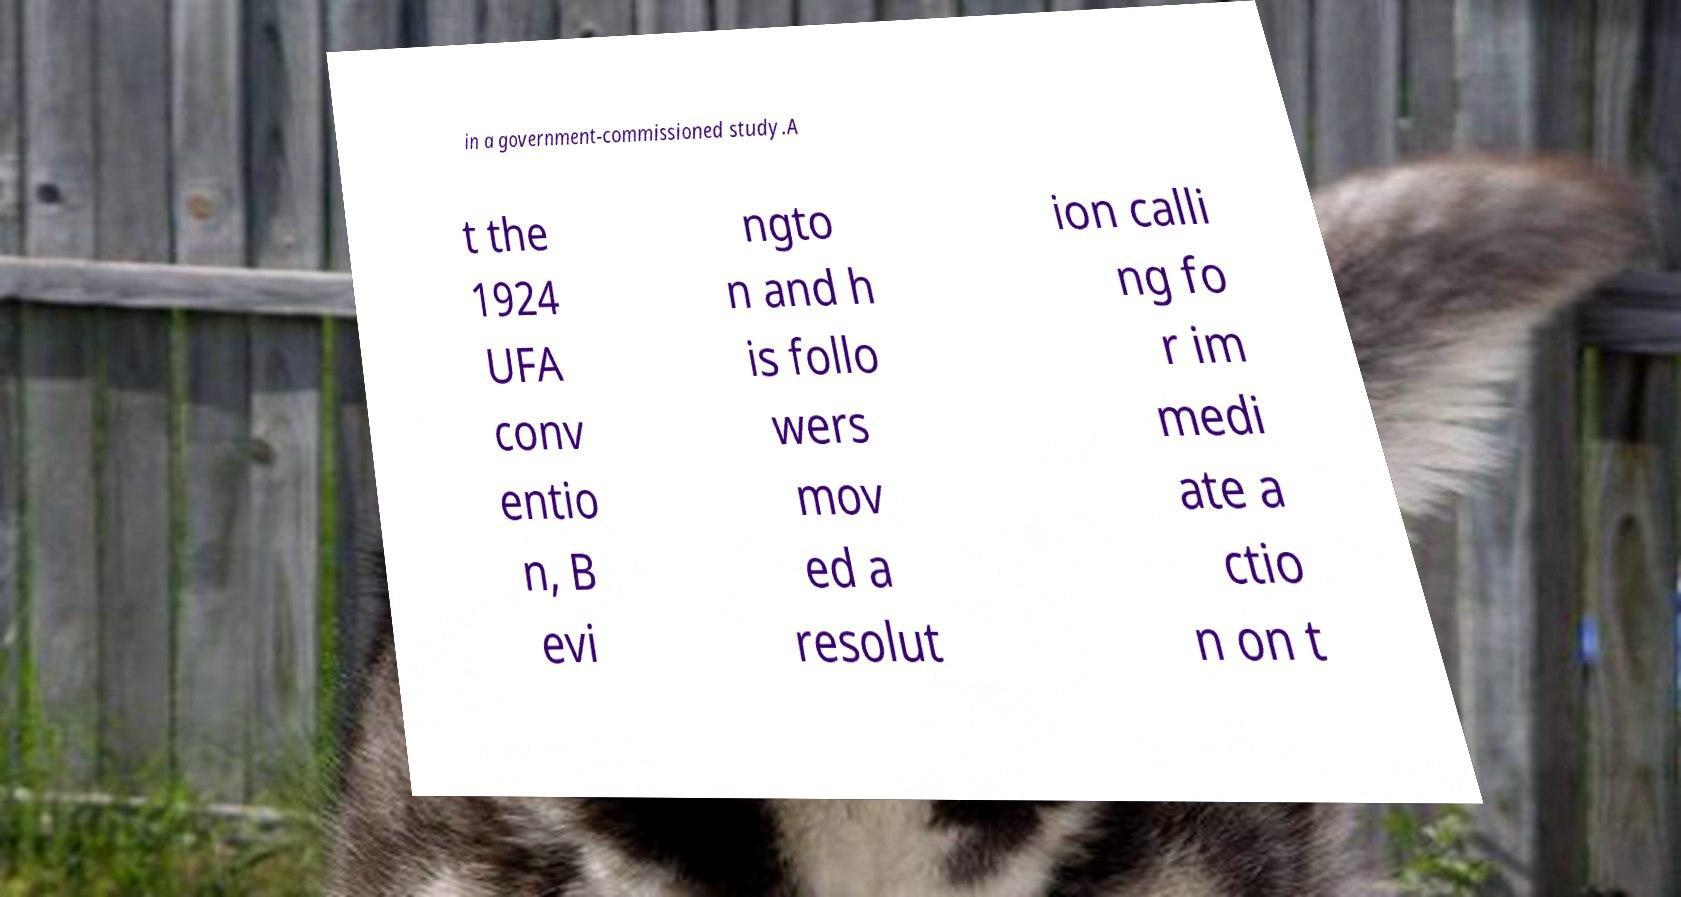Could you extract and type out the text from this image? in a government-commissioned study.A t the 1924 UFA conv entio n, B evi ngto n and h is follo wers mov ed a resolut ion calli ng fo r im medi ate a ctio n on t 